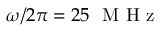Convert formula to latex. <formula><loc_0><loc_0><loc_500><loc_500>\omega / 2 \pi = 2 5 M H z</formula> 